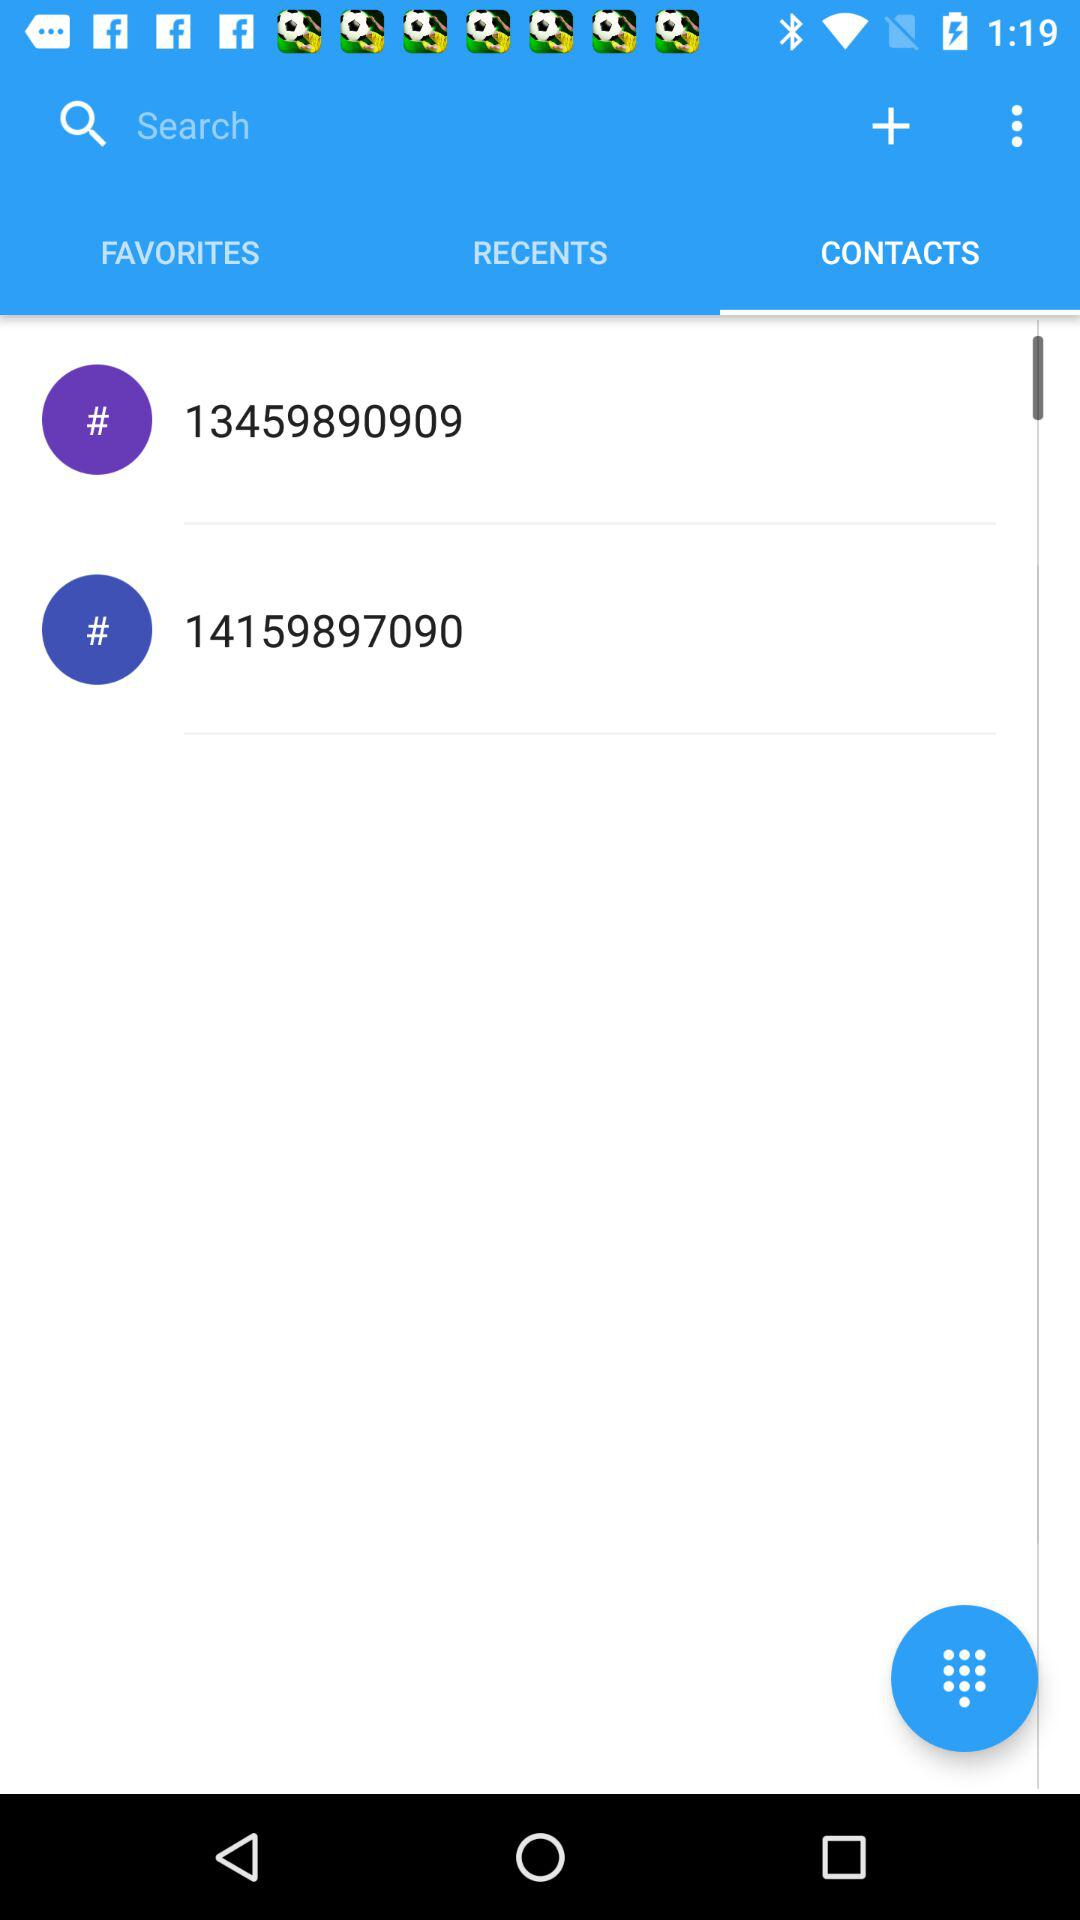Which number was most recently called?
When the provided information is insufficient, respond with <no answer>. <no answer> 